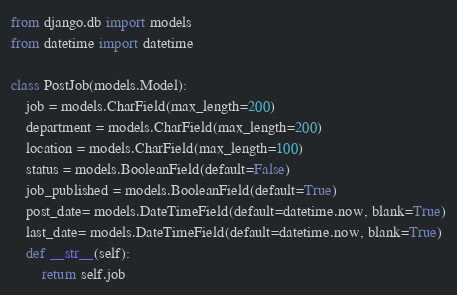<code> <loc_0><loc_0><loc_500><loc_500><_Python_>from django.db import models
from datetime import datetime

class PostJob(models.Model):
    job = models.CharField(max_length=200)
    department = models.CharField(max_length=200)
    location = models.CharField(max_length=100)
    status = models.BooleanField(default=False)
    job_published = models.BooleanField(default=True)
    post_date= models.DateTimeField(default=datetime.now, blank=True)
    last_date= models.DateTimeField(default=datetime.now, blank=True)
    def __str__(self):
        return self.job</code> 